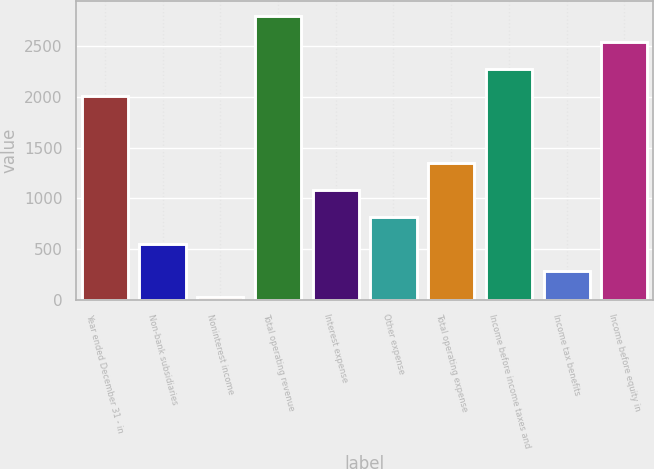Convert chart. <chart><loc_0><loc_0><loc_500><loc_500><bar_chart><fcel>Year ended December 31 - in<fcel>Non-bank subsidiaries<fcel>Noninterest income<fcel>Total operating revenue<fcel>Interest expense<fcel>Other expense<fcel>Total operating expense<fcel>Income before income taxes and<fcel>Income tax benefits<fcel>Income before equity in<nl><fcel>2011<fcel>553<fcel>24<fcel>2804.5<fcel>1082<fcel>817.5<fcel>1346.5<fcel>2275.5<fcel>288.5<fcel>2540<nl></chart> 